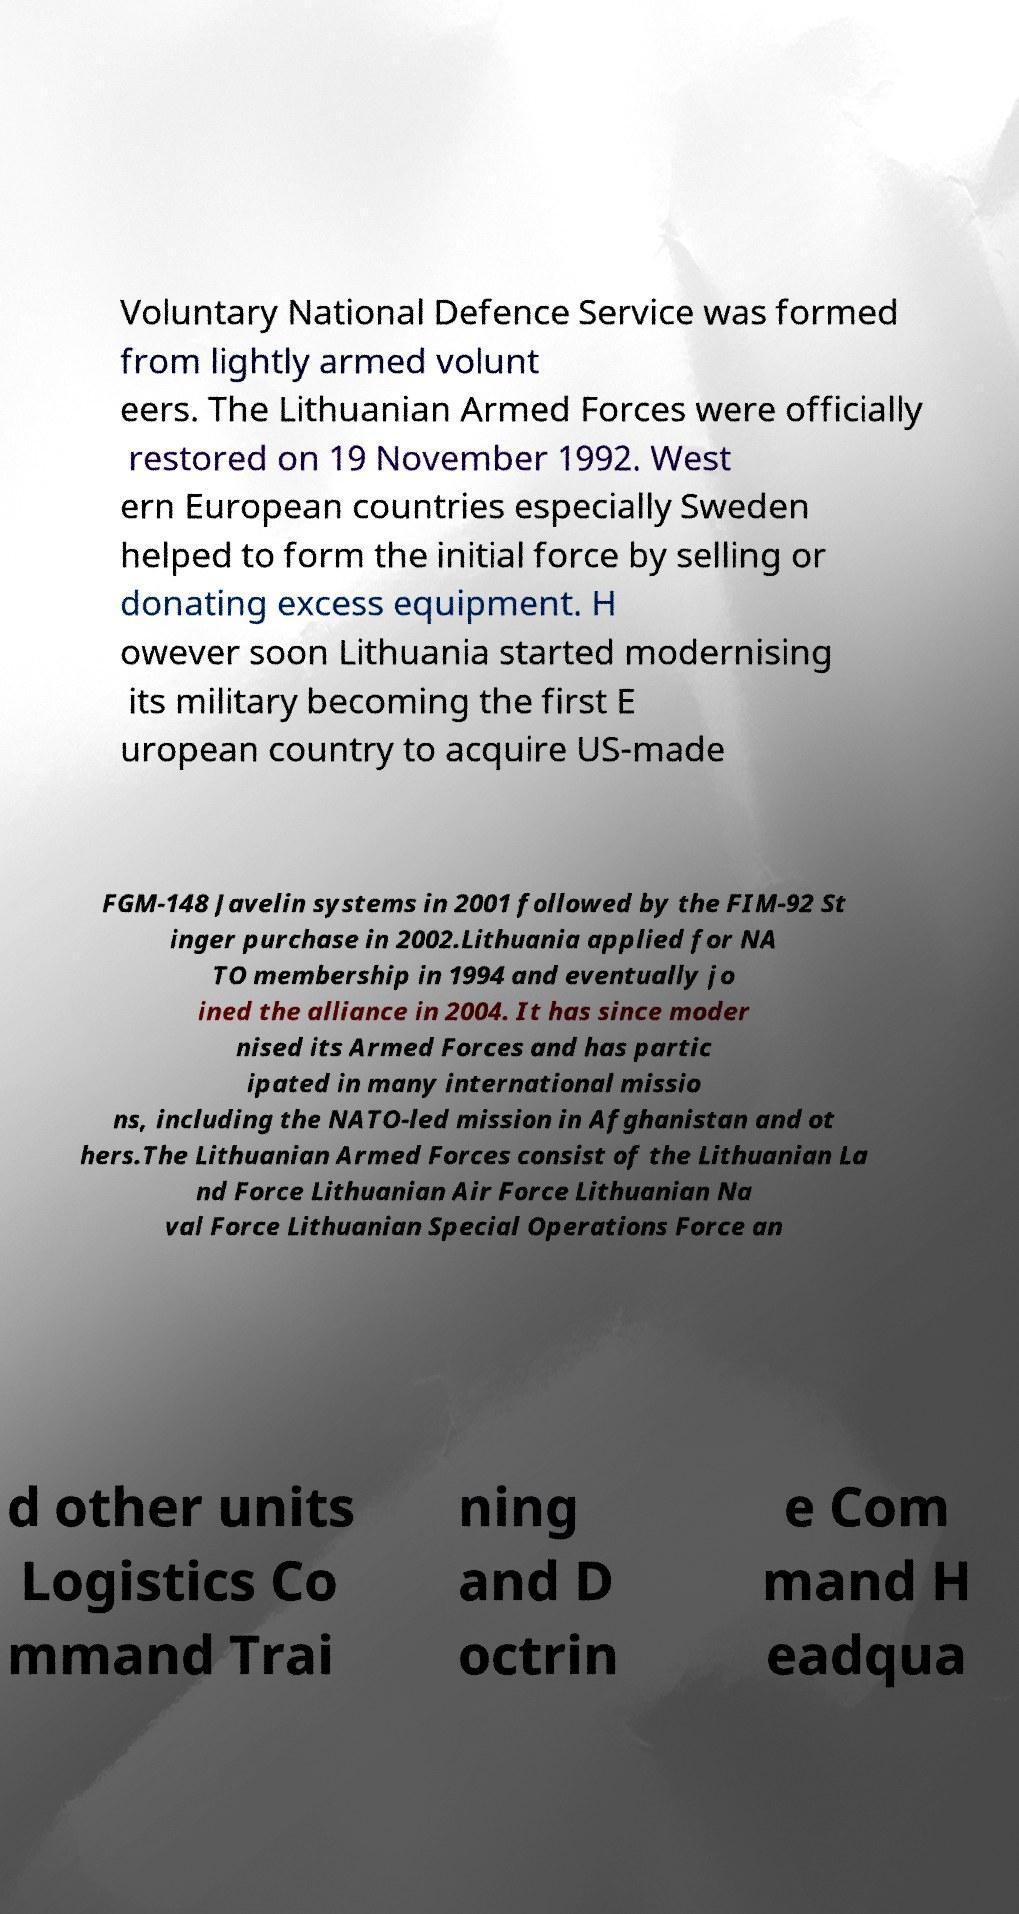Please identify and transcribe the text found in this image. Voluntary National Defence Service was formed from lightly armed volunt eers. The Lithuanian Armed Forces were officially restored on 19 November 1992. West ern European countries especially Sweden helped to form the initial force by selling or donating excess equipment. H owever soon Lithuania started modernising its military becoming the first E uropean country to acquire US-made FGM-148 Javelin systems in 2001 followed by the FIM-92 St inger purchase in 2002.Lithuania applied for NA TO membership in 1994 and eventually jo ined the alliance in 2004. It has since moder nised its Armed Forces and has partic ipated in many international missio ns, including the NATO-led mission in Afghanistan and ot hers.The Lithuanian Armed Forces consist of the Lithuanian La nd Force Lithuanian Air Force Lithuanian Na val Force Lithuanian Special Operations Force an d other units Logistics Co mmand Trai ning and D octrin e Com mand H eadqua 